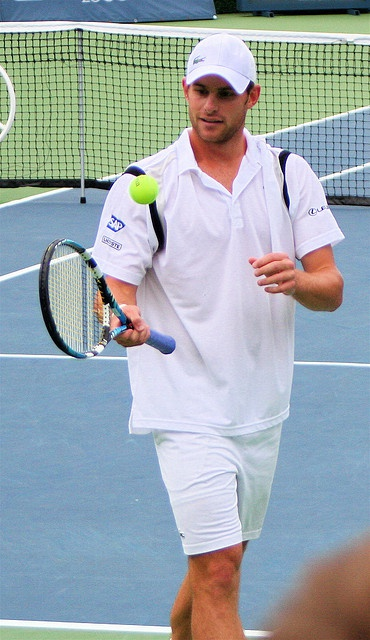Describe the objects in this image and their specific colors. I can see people in gray, lavender, darkgray, and brown tones, tennis racket in gray, darkgray, lightgray, black, and beige tones, and sports ball in gray, yellow, lime, lightgreen, and khaki tones in this image. 